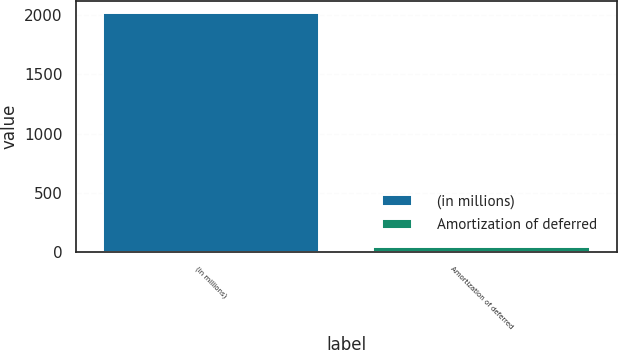Convert chart. <chart><loc_0><loc_0><loc_500><loc_500><bar_chart><fcel>(in millions)<fcel>Amortization of deferred<nl><fcel>2013<fcel>47<nl></chart> 